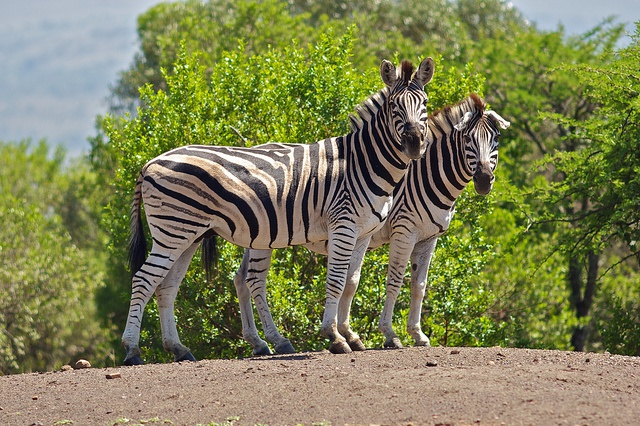Describe the objects in this image and their specific colors. I can see zebra in darkgray, black, and gray tones and zebra in darkgray, black, and gray tones in this image. 